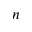Convert formula to latex. <formula><loc_0><loc_0><loc_500><loc_500>n</formula> 